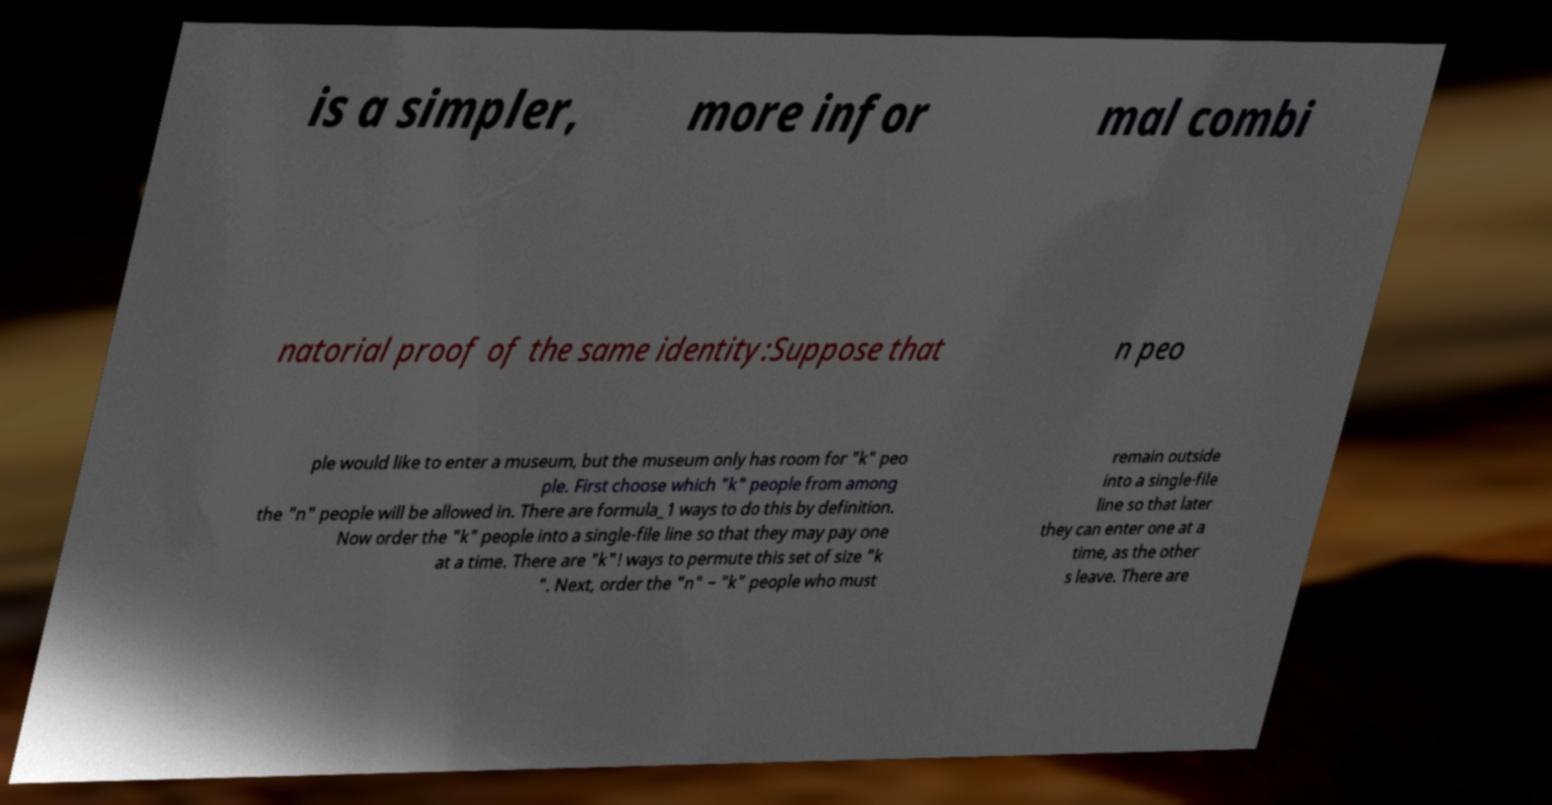Please identify and transcribe the text found in this image. is a simpler, more infor mal combi natorial proof of the same identity:Suppose that n peo ple would like to enter a museum, but the museum only has room for "k" peo ple. First choose which "k" people from among the "n" people will be allowed in. There are formula_1 ways to do this by definition. Now order the "k" people into a single-file line so that they may pay one at a time. There are "k"! ways to permute this set of size "k ". Next, order the "n" − "k" people who must remain outside into a single-file line so that later they can enter one at a time, as the other s leave. There are 